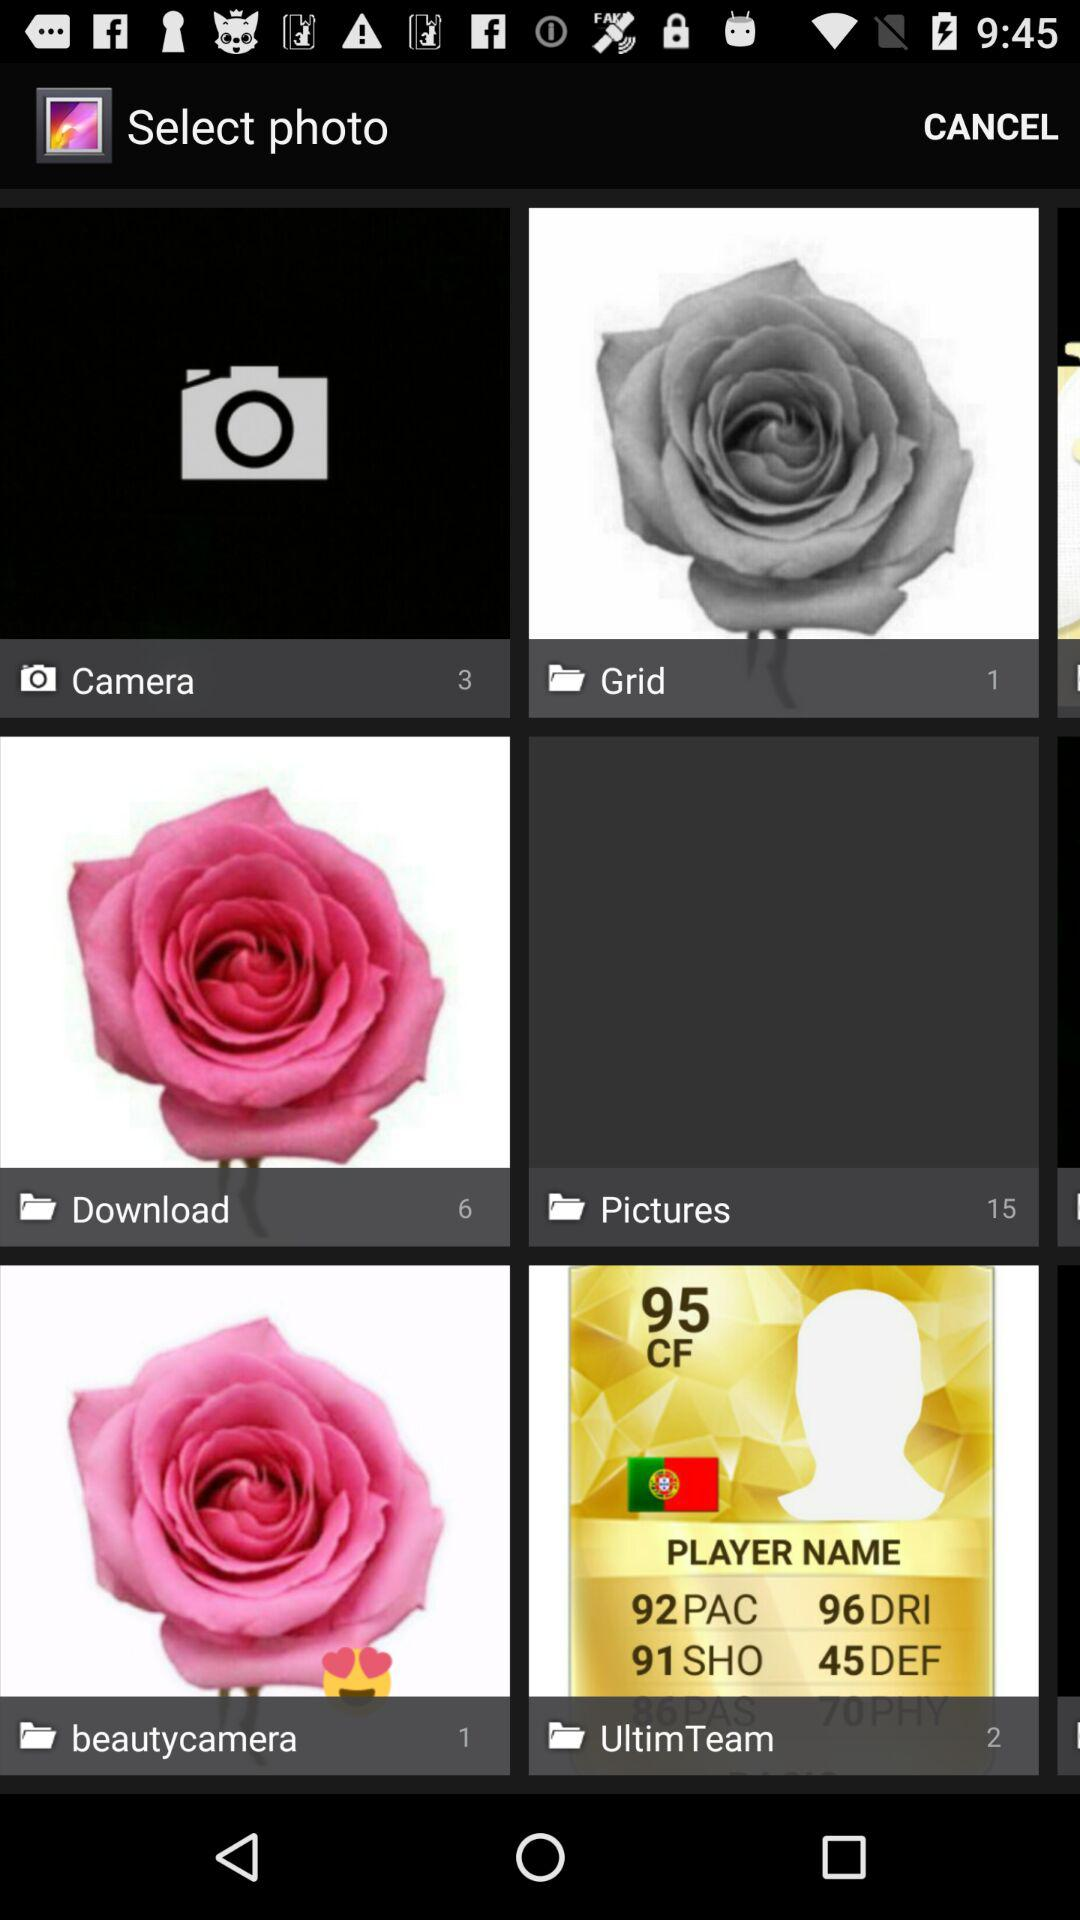How many images in total are in the "Pictures" folder? There are 15 images in total. 